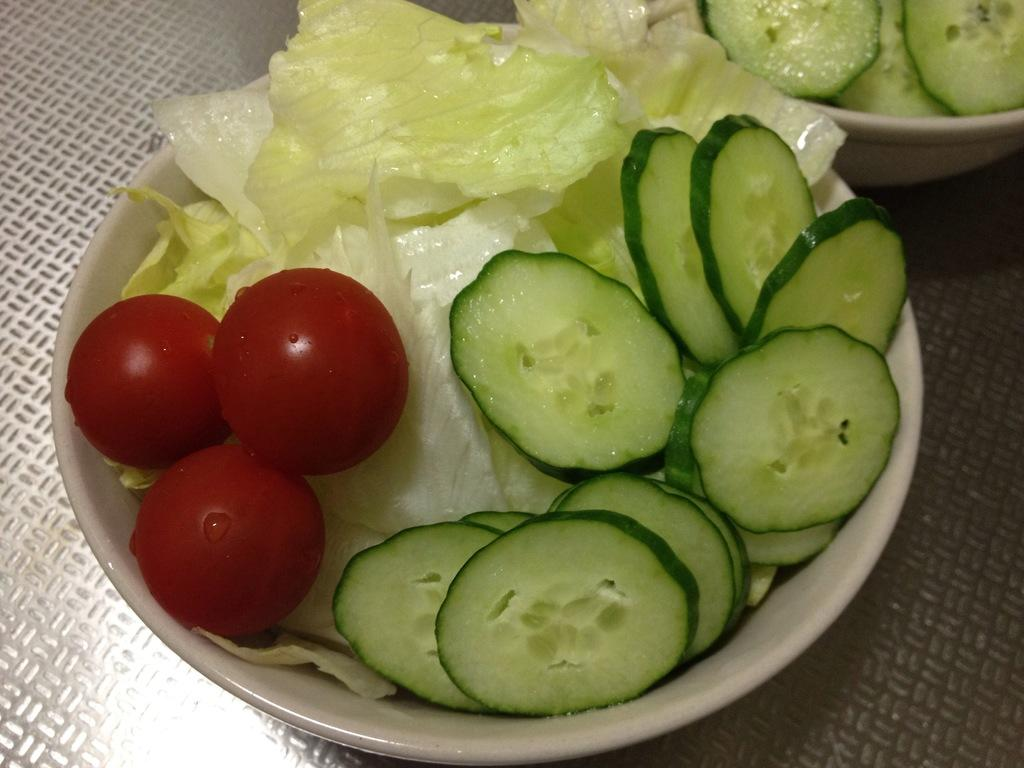What objects are present in the image that are used for serving food? There are serving bowls in the image. What type of food can be seen in the serving bowls? The serving bowls contain vegetables. What type of stamp is visible on the vegetables in the image? There is no stamp visible on the vegetables in the image. How many dimes are present in the image? There are no dimes present in the image. 